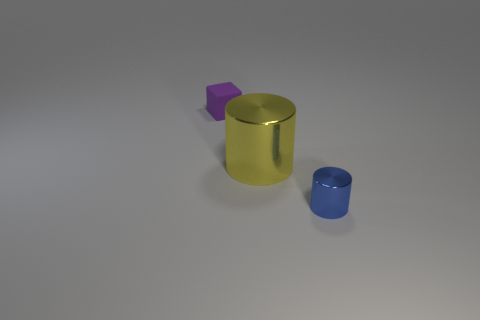Add 2 large yellow metal objects. How many objects exist? 5 Subtract 1 blocks. How many blocks are left? 0 Subtract all cylinders. How many objects are left? 1 Add 1 big yellow cylinders. How many big yellow cylinders are left? 2 Add 2 big metallic things. How many big metallic things exist? 3 Subtract 0 gray spheres. How many objects are left? 3 Subtract all brown cylinders. Subtract all brown cubes. How many cylinders are left? 2 Subtract all large shiny things. Subtract all small metallic things. How many objects are left? 1 